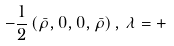<formula> <loc_0><loc_0><loc_500><loc_500>- \frac { 1 } { 2 } \left ( \bar { \rho } , 0 , 0 , \bar { \rho } \right ) , \, \lambda = +</formula> 